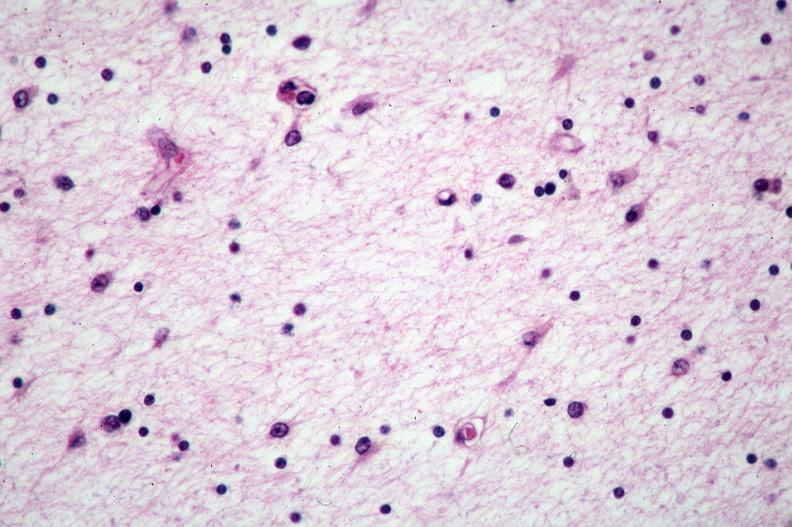does this image show brain, pick 's disease?
Answer the question using a single word or phrase. Yes 